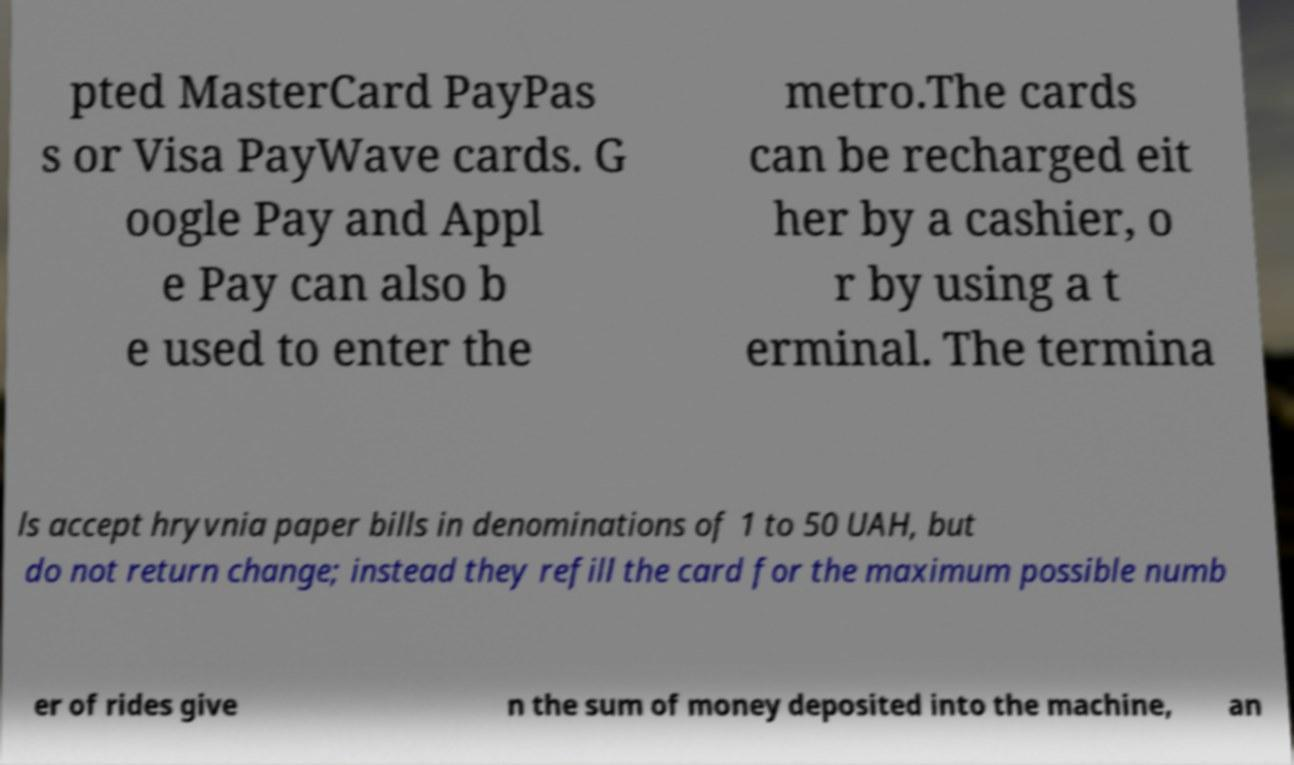Please identify and transcribe the text found in this image. pted MasterCard PayPas s or Visa PayWave cards. G oogle Pay and Appl e Pay can also b e used to enter the metro.The cards can be recharged eit her by a cashier, o r by using a t erminal. The termina ls accept hryvnia paper bills in denominations of 1 to 50 UAH, but do not return change; instead they refill the card for the maximum possible numb er of rides give n the sum of money deposited into the machine, an 